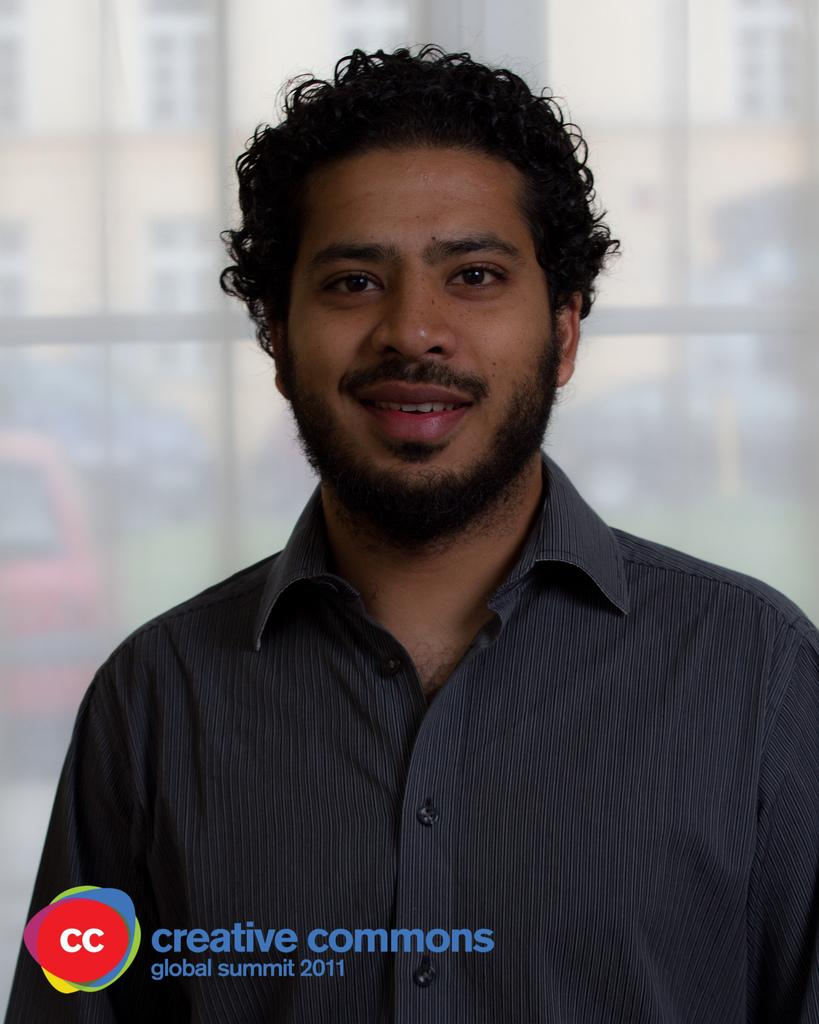Who is the main subject in the image? There is a man in the front of the image. How would you describe the background of the image? The background of the image is blurry. What can be seen in the distance behind the man? There is a building visible in the background. Are there any other objects or features in the background? Yes, there are objects in the background. Can you describe any additional elements present in the image? There is a watermark at the bottom of the image. What type of stove is being used by the man in the image? There is no stove present in the image; it features a man in the foreground and a blurry background with a building and other objects. 